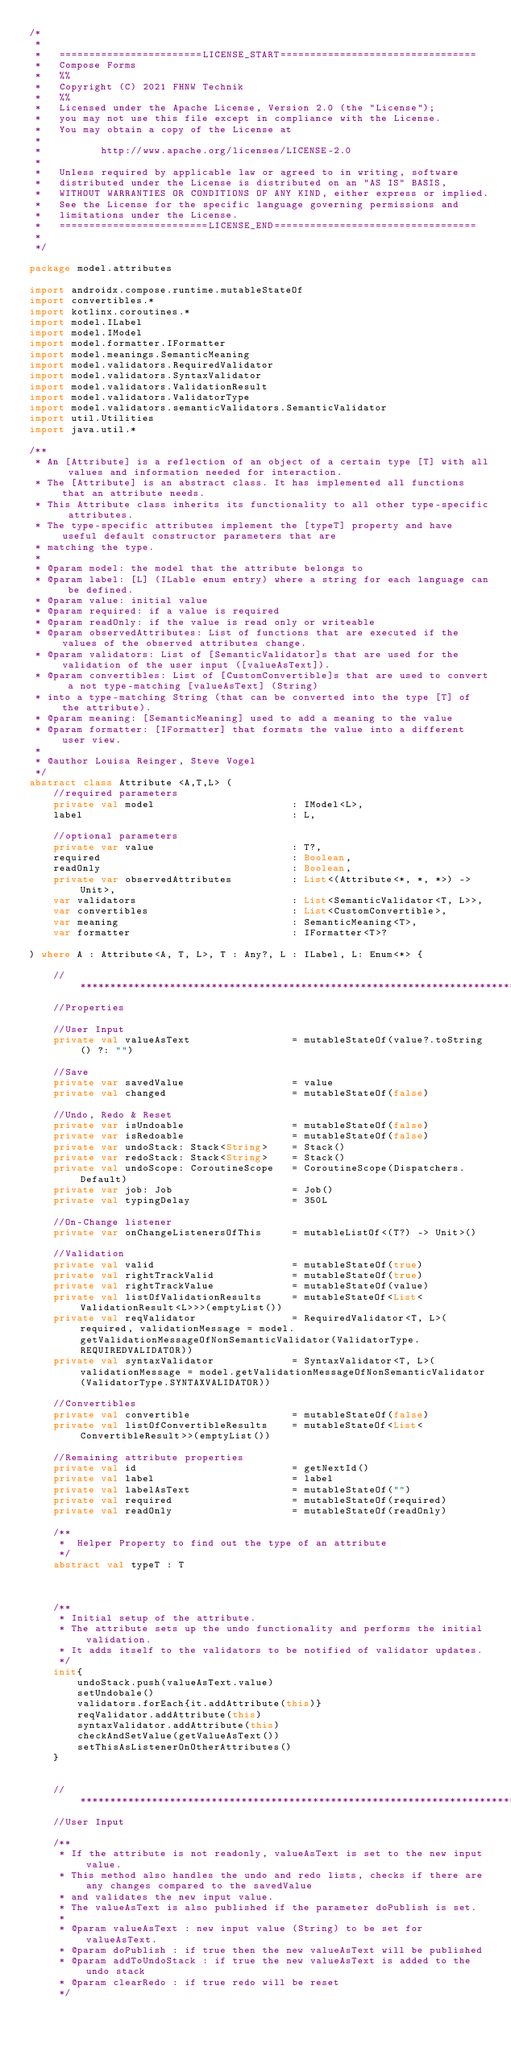<code> <loc_0><loc_0><loc_500><loc_500><_Kotlin_>/*
 *
 *   ========================LICENSE_START=================================
 *   Compose Forms
 *   %%
 *   Copyright (C) 2021 FHNW Technik
 *   %%
 *   Licensed under the Apache License, Version 2.0 (the "License");
 *   you may not use this file except in compliance with the License.
 *   You may obtain a copy of the License at
 *
 *          http://www.apache.org/licenses/LICENSE-2.0
 *
 *   Unless required by applicable law or agreed to in writing, software
 *   distributed under the License is distributed on an "AS IS" BASIS,
 *   WITHOUT WARRANTIES OR CONDITIONS OF ANY KIND, either express or implied.
 *   See the License for the specific language governing permissions and
 *   limitations under the License.
 *   =========================LICENSE_END==================================
 *
 */

package model.attributes

import androidx.compose.runtime.mutableStateOf
import convertibles.*
import kotlinx.coroutines.*
import model.ILabel
import model.IModel
import model.formatter.IFormatter
import model.meanings.SemanticMeaning
import model.validators.RequiredValidator
import model.validators.SyntaxValidator
import model.validators.ValidationResult
import model.validators.ValidatorType
import model.validators.semanticValidators.SemanticValidator
import util.Utilities
import java.util.*

/**
 * An [Attribute] is a reflection of an object of a certain type [T] with all values and information needed for interaction.
 * The [Attribute] is an abstract class. It has implemented all functions that an attribute needs.
 * This Attribute class inherits its functionality to all other type-specific attributes.
 * The type-specific attributes implement the [typeT] property and have useful default constructor parameters that are
 * matching the type.
 *
 * @param model: the model that the attribute belongs to
 * @param label: [L] (ILable enum entry) where a string for each language can be defined.
 * @param value: initial value
 * @param required: if a value is required
 * @param readOnly: if the value is read only or writeable
 * @param observedAttributes: List of functions that are executed if the values of the observed attributes change.
 * @param validators: List of [SemanticValidator]s that are used for the validation of the user input ([valueAsText]).
 * @param convertibles: List of [CustomConvertible]s that are used to convert a not type-matching [valueAsText] (String)
 * into a type-matching String (that can be converted into the type [T] of the attribute).
 * @param meaning: [SemanticMeaning] used to add a meaning to the value
 * @param formatter: [IFormatter] that formats the value into a different user view.
 *
 * @author Louisa Reinger, Steve Vogel
 */
abstract class Attribute <A,T,L> (
    //required parameters
    private val model                       : IModel<L>,
    label                                   : L,

    //optional parameters
    private var value                       : T?,
    required                                : Boolean,
    readOnly                                : Boolean,
    private var observedAttributes          : List<(Attribute<*, *, *>) -> Unit>,
    var validators                          : List<SemanticValidator<T, L>>,
    var convertibles                        : List<CustomConvertible>,
    var meaning                             : SemanticMeaning<T>,
    var formatter                           : IFormatter<T>?

) where A : Attribute<A, T, L>, T : Any?, L : ILabel, L: Enum<*> {

    //******************************************************************************************************************
    //Properties

    //User Input
    private val valueAsText                 = mutableStateOf(value?.toString() ?: "")

    //Save
    private var savedValue                  = value
    private val changed                     = mutableStateOf(false)

    //Undo, Redo & Reset
    private var isUndoable                  = mutableStateOf(false)
    private var isRedoable                  = mutableStateOf(false)
    private var undoStack: Stack<String>    = Stack()
    private var redoStack: Stack<String>    = Stack()
    private val undoScope: CoroutineScope   = CoroutineScope(Dispatchers.Default)
    private var job: Job                    = Job()
    private val typingDelay                 = 350L

    //On-Change listener
    private var onChangeListenersOfThis     = mutableListOf<(T?) -> Unit>()

    //Validation
    private val valid                       = mutableStateOf(true)
    private val rightTrackValid             = mutableStateOf(true)
    private val rightTrackValue             = mutableStateOf(value)
    private val listOfValidationResults     = mutableStateOf<List<ValidationResult<L>>>(emptyList())
    private val reqValidator                = RequiredValidator<T, L>(required, validationMessage = model.getValidationMessageOfNonSemanticValidator(ValidatorType.REQUIREDVALIDATOR))
    private val syntaxValidator             = SyntaxValidator<T, L>(validationMessage = model.getValidationMessageOfNonSemanticValidator(ValidatorType.SYNTAXVALIDATOR))

    //Convertibles
    private val convertible                 = mutableStateOf(false)
    private val listOfConvertibleResults    = mutableStateOf<List<ConvertibleResult>>(emptyList())

    //Remaining attribute properties
    private val id                          = getNextId()
    private val label                       = label
    private val labelAsText                 = mutableStateOf("")
    private val required                    = mutableStateOf(required)
    private val readOnly                    = mutableStateOf(readOnly)

    /**
     *  Helper Property to find out the type of an attribute
     */
    abstract val typeT : T



    /**
     * Initial setup of the attribute.
     * The attribute sets up the undo functionality and performs the initial validation.
     * It adds itself to the validators to be notified of validator updates.
     */
    init{
        undoStack.push(valueAsText.value)
        setUndobale()
        validators.forEach{it.addAttribute(this)}
        reqValidator.addAttribute(this)
        syntaxValidator.addAttribute(this)
        checkAndSetValue(getValueAsText())
        setThisAsListenerOnOtherAttributes()
    }


    //******************************************************************************************************************
    //User Input

    /**
     * If the attribute is not readonly, valueAsText is set to the new input value.
     * This method also handles the undo and redo lists, checks if there are any changes compared to the savedValue
     * and validates the new input value.
     * The valueAsText is also published if the parameter doPublish is set.
     *
     * @param valueAsText : new input value (String) to be set for valueAsText.
     * @param doPublish : if true then the new valueAsText will be published
     * @param addToUndoStack : if true the new valueAsText is added to the undo stack
     * @param clearRedo : if true redo will be reset
     */</code> 